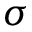<formula> <loc_0><loc_0><loc_500><loc_500>\sigma</formula> 